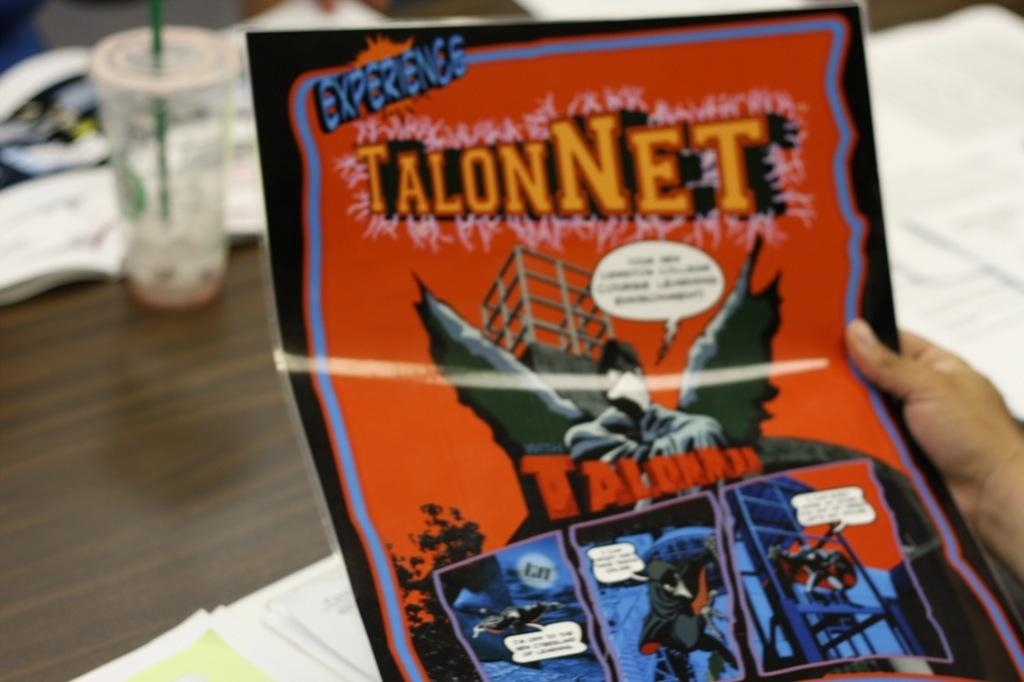<image>
Describe the image concisely. Someone is holding an issue of a comic called TalonNet. 